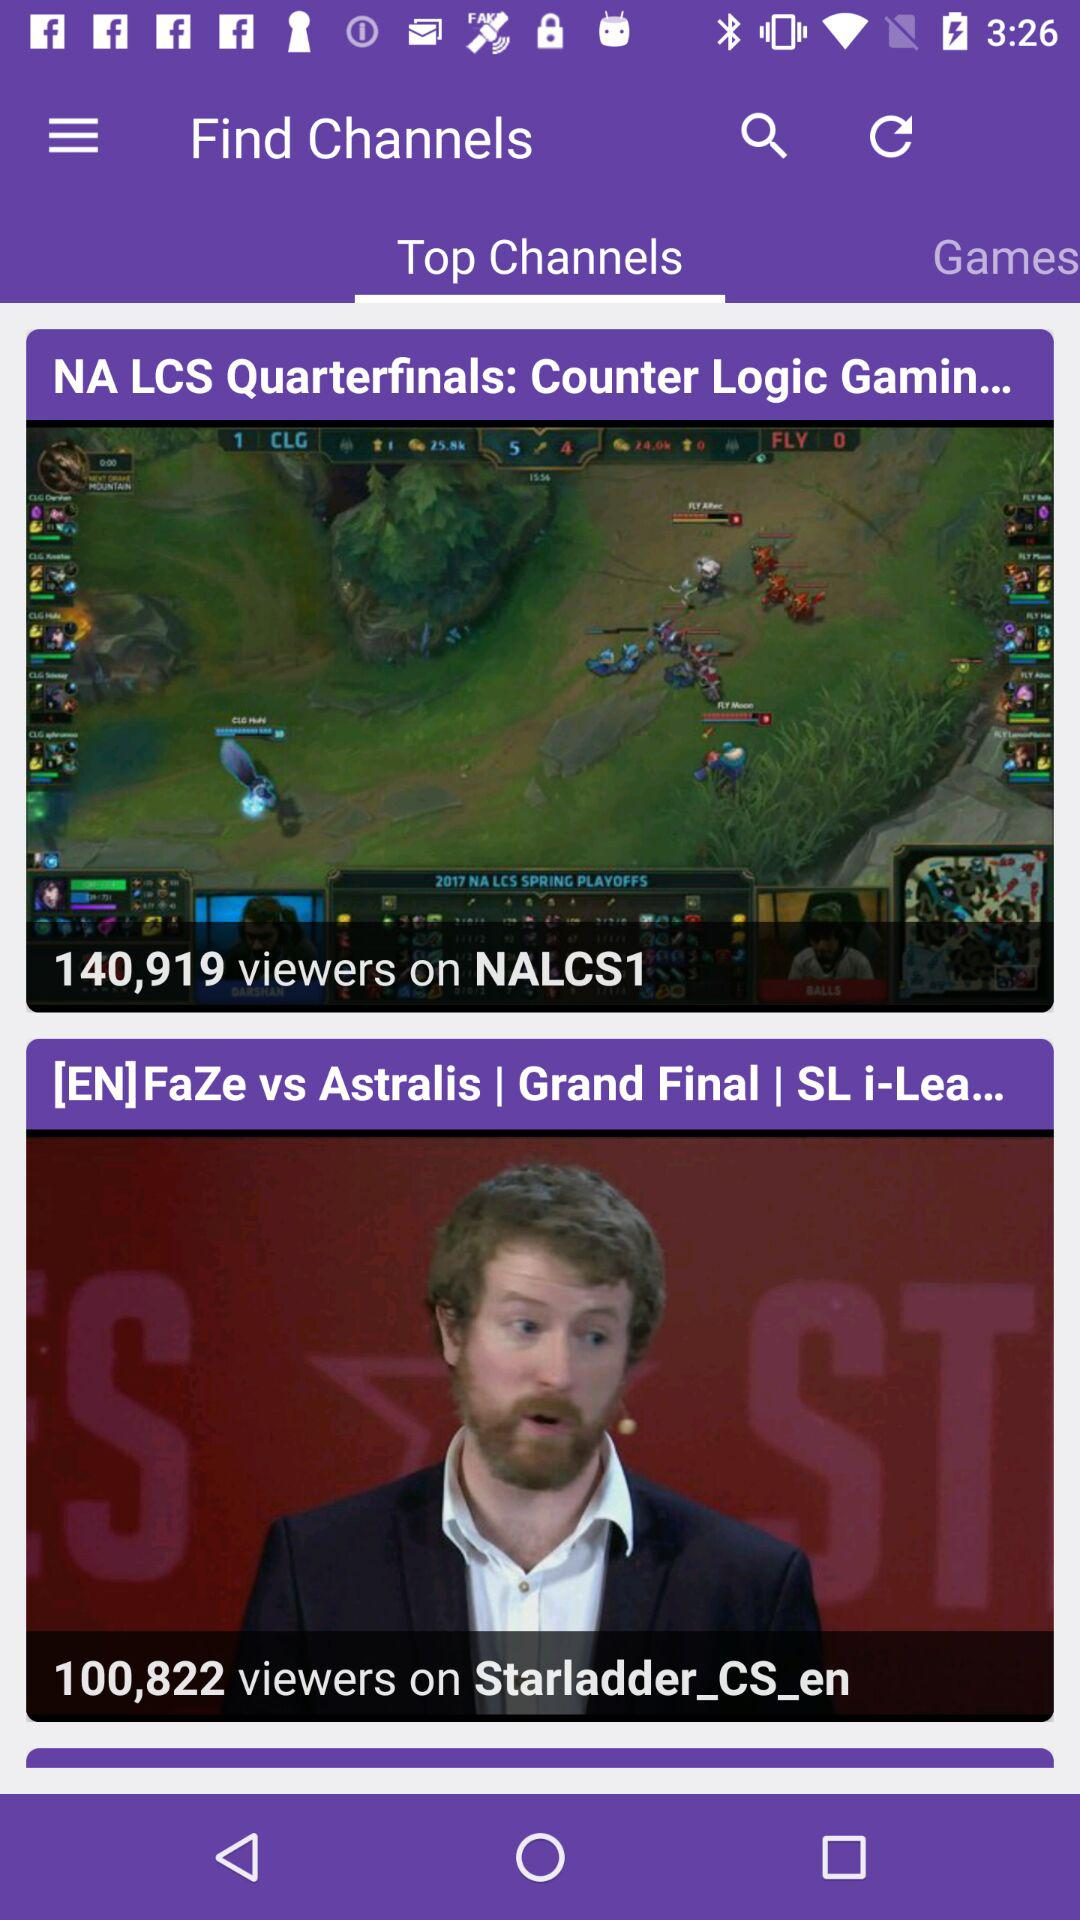Which option is selected in "Find Channels"? The selected option is "Top Channels". 